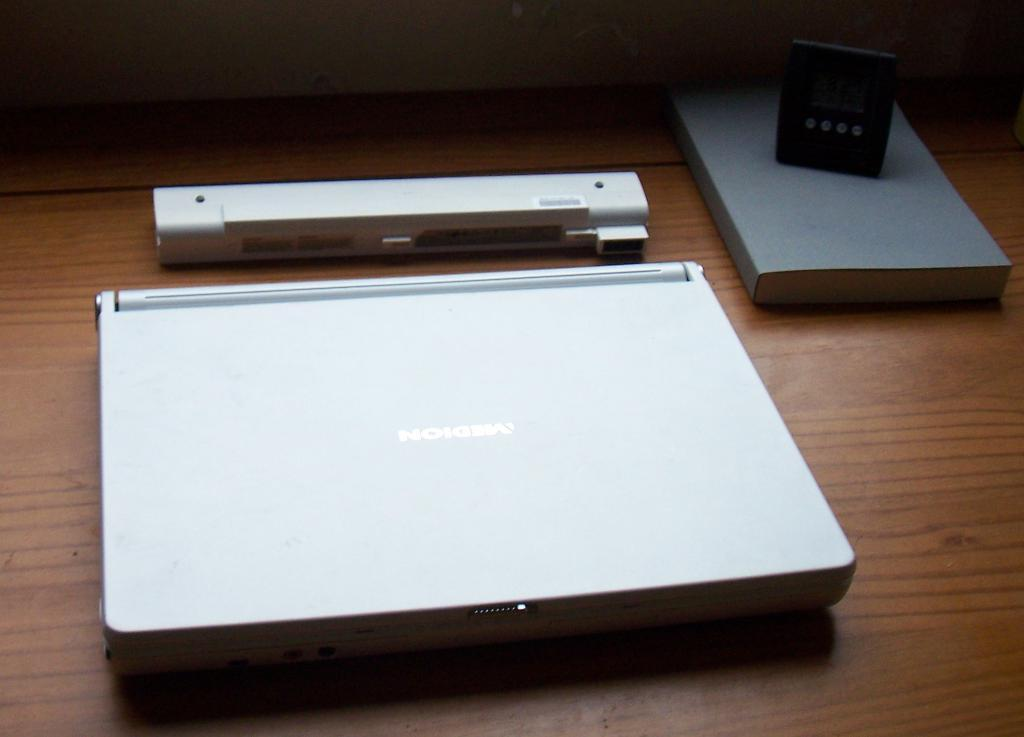What piece of furniture is in the image? There is a table in the image. What electronic device is on the table? A laptop is present on the table. What else can be seen on the table besides the laptop? There is a book and other electronic devices visible on the table. Can you see a potato on the table in the image? There is no potato present on the table in the image. 